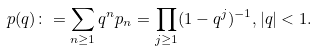Convert formula to latex. <formula><loc_0><loc_0><loc_500><loc_500>p ( q ) \colon = \sum _ { n \geq 1 } q ^ { n } p _ { n } = \prod _ { j \geq 1 } ( 1 - q ^ { j } ) ^ { - 1 } , | q | < 1 .</formula> 